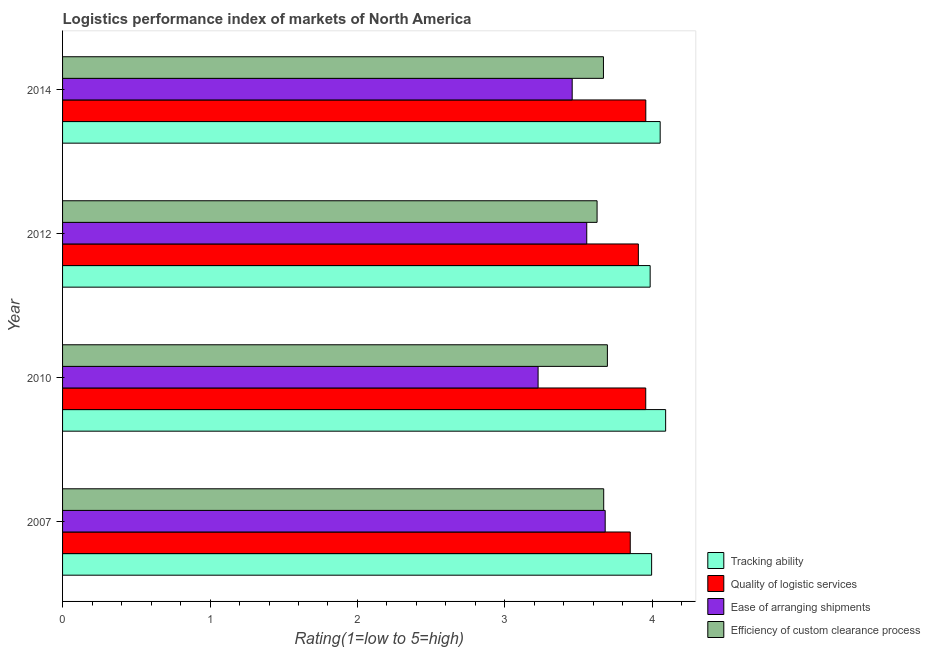How many different coloured bars are there?
Provide a short and direct response. 4. Are the number of bars per tick equal to the number of legend labels?
Give a very brief answer. Yes. In how many cases, is the number of bars for a given year not equal to the number of legend labels?
Ensure brevity in your answer.  0. What is the lpi rating of efficiency of custom clearance process in 2010?
Provide a short and direct response. 3.69. Across all years, what is the maximum lpi rating of quality of logistic services?
Give a very brief answer. 3.96. Across all years, what is the minimum lpi rating of efficiency of custom clearance process?
Your response must be concise. 3.62. In which year was the lpi rating of quality of logistic services maximum?
Offer a very short reply. 2014. In which year was the lpi rating of efficiency of custom clearance process minimum?
Ensure brevity in your answer.  2012. What is the total lpi rating of ease of arranging shipments in the graph?
Your answer should be compact. 13.92. What is the difference between the lpi rating of ease of arranging shipments in 2014 and the lpi rating of efficiency of custom clearance process in 2007?
Provide a succinct answer. -0.21. What is the average lpi rating of quality of logistic services per year?
Ensure brevity in your answer.  3.92. In the year 2014, what is the difference between the lpi rating of ease of arranging shipments and lpi rating of efficiency of custom clearance process?
Your answer should be compact. -0.21. Is the lpi rating of ease of arranging shipments in 2012 less than that in 2014?
Your answer should be compact. No. Is the difference between the lpi rating of quality of logistic services in 2007 and 2010 greater than the difference between the lpi rating of tracking ability in 2007 and 2010?
Your answer should be very brief. No. What is the difference between the highest and the lowest lpi rating of quality of logistic services?
Your answer should be very brief. 0.11. Is the sum of the lpi rating of ease of arranging shipments in 2010 and 2014 greater than the maximum lpi rating of efficiency of custom clearance process across all years?
Offer a terse response. Yes. Is it the case that in every year, the sum of the lpi rating of tracking ability and lpi rating of ease of arranging shipments is greater than the sum of lpi rating of quality of logistic services and lpi rating of efficiency of custom clearance process?
Provide a succinct answer. No. What does the 4th bar from the top in 2010 represents?
Make the answer very short. Tracking ability. What does the 4th bar from the bottom in 2012 represents?
Offer a terse response. Efficiency of custom clearance process. Is it the case that in every year, the sum of the lpi rating of tracking ability and lpi rating of quality of logistic services is greater than the lpi rating of ease of arranging shipments?
Keep it short and to the point. Yes. Are the values on the major ticks of X-axis written in scientific E-notation?
Offer a very short reply. No. Does the graph contain any zero values?
Provide a succinct answer. No. Does the graph contain grids?
Provide a short and direct response. No. Where does the legend appear in the graph?
Your response must be concise. Bottom right. How are the legend labels stacked?
Make the answer very short. Vertical. What is the title of the graph?
Provide a short and direct response. Logistics performance index of markets of North America. Does "Fiscal policy" appear as one of the legend labels in the graph?
Give a very brief answer. No. What is the label or title of the X-axis?
Make the answer very short. Rating(1=low to 5=high). What is the label or title of the Y-axis?
Offer a very short reply. Year. What is the Rating(1=low to 5=high) in Tracking ability in 2007?
Your answer should be very brief. 4. What is the Rating(1=low to 5=high) in Quality of logistic services in 2007?
Make the answer very short. 3.85. What is the Rating(1=low to 5=high) in Ease of arranging shipments in 2007?
Your answer should be very brief. 3.68. What is the Rating(1=low to 5=high) of Efficiency of custom clearance process in 2007?
Keep it short and to the point. 3.67. What is the Rating(1=low to 5=high) in Tracking ability in 2010?
Make the answer very short. 4.09. What is the Rating(1=low to 5=high) in Quality of logistic services in 2010?
Offer a very short reply. 3.96. What is the Rating(1=low to 5=high) in Ease of arranging shipments in 2010?
Provide a short and direct response. 3.23. What is the Rating(1=low to 5=high) in Efficiency of custom clearance process in 2010?
Ensure brevity in your answer.  3.69. What is the Rating(1=low to 5=high) of Tracking ability in 2012?
Provide a succinct answer. 3.98. What is the Rating(1=low to 5=high) in Quality of logistic services in 2012?
Give a very brief answer. 3.9. What is the Rating(1=low to 5=high) in Ease of arranging shipments in 2012?
Make the answer very short. 3.56. What is the Rating(1=low to 5=high) of Efficiency of custom clearance process in 2012?
Your answer should be compact. 3.62. What is the Rating(1=low to 5=high) in Tracking ability in 2014?
Offer a very short reply. 4.05. What is the Rating(1=low to 5=high) in Quality of logistic services in 2014?
Make the answer very short. 3.96. What is the Rating(1=low to 5=high) of Ease of arranging shipments in 2014?
Provide a succinct answer. 3.46. What is the Rating(1=low to 5=high) of Efficiency of custom clearance process in 2014?
Provide a succinct answer. 3.67. Across all years, what is the maximum Rating(1=low to 5=high) in Tracking ability?
Provide a succinct answer. 4.09. Across all years, what is the maximum Rating(1=low to 5=high) in Quality of logistic services?
Give a very brief answer. 3.96. Across all years, what is the maximum Rating(1=low to 5=high) of Ease of arranging shipments?
Ensure brevity in your answer.  3.68. Across all years, what is the maximum Rating(1=low to 5=high) of Efficiency of custom clearance process?
Provide a succinct answer. 3.69. Across all years, what is the minimum Rating(1=low to 5=high) in Tracking ability?
Make the answer very short. 3.98. Across all years, what is the minimum Rating(1=low to 5=high) of Quality of logistic services?
Offer a very short reply. 3.85. Across all years, what is the minimum Rating(1=low to 5=high) of Ease of arranging shipments?
Make the answer very short. 3.23. Across all years, what is the minimum Rating(1=low to 5=high) in Efficiency of custom clearance process?
Provide a short and direct response. 3.62. What is the total Rating(1=low to 5=high) of Tracking ability in the graph?
Your answer should be compact. 16.12. What is the total Rating(1=low to 5=high) of Quality of logistic services in the graph?
Keep it short and to the point. 15.67. What is the total Rating(1=low to 5=high) of Ease of arranging shipments in the graph?
Offer a very short reply. 13.92. What is the total Rating(1=low to 5=high) of Efficiency of custom clearance process in the graph?
Keep it short and to the point. 14.66. What is the difference between the Rating(1=low to 5=high) of Tracking ability in 2007 and that in 2010?
Give a very brief answer. -0.1. What is the difference between the Rating(1=low to 5=high) of Quality of logistic services in 2007 and that in 2010?
Give a very brief answer. -0.1. What is the difference between the Rating(1=low to 5=high) in Ease of arranging shipments in 2007 and that in 2010?
Offer a terse response. 0.46. What is the difference between the Rating(1=low to 5=high) of Efficiency of custom clearance process in 2007 and that in 2010?
Offer a terse response. -0.03. What is the difference between the Rating(1=low to 5=high) of Quality of logistic services in 2007 and that in 2012?
Your answer should be very brief. -0.06. What is the difference between the Rating(1=low to 5=high) of Ease of arranging shipments in 2007 and that in 2012?
Your response must be concise. 0.12. What is the difference between the Rating(1=low to 5=high) in Efficiency of custom clearance process in 2007 and that in 2012?
Offer a very short reply. 0.04. What is the difference between the Rating(1=low to 5=high) in Tracking ability in 2007 and that in 2014?
Provide a succinct answer. -0.06. What is the difference between the Rating(1=low to 5=high) of Quality of logistic services in 2007 and that in 2014?
Provide a succinct answer. -0.11. What is the difference between the Rating(1=low to 5=high) in Ease of arranging shipments in 2007 and that in 2014?
Offer a very short reply. 0.22. What is the difference between the Rating(1=low to 5=high) in Efficiency of custom clearance process in 2007 and that in 2014?
Make the answer very short. 0. What is the difference between the Rating(1=low to 5=high) of Tracking ability in 2010 and that in 2012?
Keep it short and to the point. 0.1. What is the difference between the Rating(1=low to 5=high) in Quality of logistic services in 2010 and that in 2012?
Your answer should be very brief. 0.05. What is the difference between the Rating(1=low to 5=high) in Ease of arranging shipments in 2010 and that in 2012?
Provide a short and direct response. -0.33. What is the difference between the Rating(1=low to 5=high) in Efficiency of custom clearance process in 2010 and that in 2012?
Ensure brevity in your answer.  0.07. What is the difference between the Rating(1=low to 5=high) in Tracking ability in 2010 and that in 2014?
Provide a succinct answer. 0.04. What is the difference between the Rating(1=low to 5=high) of Quality of logistic services in 2010 and that in 2014?
Your answer should be very brief. -0. What is the difference between the Rating(1=low to 5=high) of Ease of arranging shipments in 2010 and that in 2014?
Your response must be concise. -0.23. What is the difference between the Rating(1=low to 5=high) of Efficiency of custom clearance process in 2010 and that in 2014?
Keep it short and to the point. 0.03. What is the difference between the Rating(1=low to 5=high) in Tracking ability in 2012 and that in 2014?
Your answer should be compact. -0.07. What is the difference between the Rating(1=low to 5=high) in Quality of logistic services in 2012 and that in 2014?
Your response must be concise. -0.05. What is the difference between the Rating(1=low to 5=high) in Ease of arranging shipments in 2012 and that in 2014?
Your response must be concise. 0.1. What is the difference between the Rating(1=low to 5=high) of Efficiency of custom clearance process in 2012 and that in 2014?
Your response must be concise. -0.04. What is the difference between the Rating(1=low to 5=high) in Tracking ability in 2007 and the Rating(1=low to 5=high) in Ease of arranging shipments in 2010?
Provide a short and direct response. 0.77. What is the difference between the Rating(1=low to 5=high) of Quality of logistic services in 2007 and the Rating(1=low to 5=high) of Ease of arranging shipments in 2010?
Provide a succinct answer. 0.62. What is the difference between the Rating(1=low to 5=high) of Quality of logistic services in 2007 and the Rating(1=low to 5=high) of Efficiency of custom clearance process in 2010?
Give a very brief answer. 0.15. What is the difference between the Rating(1=low to 5=high) of Ease of arranging shipments in 2007 and the Rating(1=low to 5=high) of Efficiency of custom clearance process in 2010?
Your answer should be very brief. -0.01. What is the difference between the Rating(1=low to 5=high) of Tracking ability in 2007 and the Rating(1=low to 5=high) of Quality of logistic services in 2012?
Offer a very short reply. 0.09. What is the difference between the Rating(1=low to 5=high) of Tracking ability in 2007 and the Rating(1=low to 5=high) of Ease of arranging shipments in 2012?
Your response must be concise. 0.44. What is the difference between the Rating(1=low to 5=high) in Tracking ability in 2007 and the Rating(1=low to 5=high) in Efficiency of custom clearance process in 2012?
Keep it short and to the point. 0.37. What is the difference between the Rating(1=low to 5=high) of Quality of logistic services in 2007 and the Rating(1=low to 5=high) of Ease of arranging shipments in 2012?
Provide a short and direct response. 0.29. What is the difference between the Rating(1=low to 5=high) of Quality of logistic services in 2007 and the Rating(1=low to 5=high) of Efficiency of custom clearance process in 2012?
Your response must be concise. 0.23. What is the difference between the Rating(1=low to 5=high) of Ease of arranging shipments in 2007 and the Rating(1=low to 5=high) of Efficiency of custom clearance process in 2012?
Give a very brief answer. 0.06. What is the difference between the Rating(1=low to 5=high) of Tracking ability in 2007 and the Rating(1=low to 5=high) of Quality of logistic services in 2014?
Provide a succinct answer. 0.04. What is the difference between the Rating(1=low to 5=high) in Tracking ability in 2007 and the Rating(1=low to 5=high) in Ease of arranging shipments in 2014?
Your answer should be very brief. 0.54. What is the difference between the Rating(1=low to 5=high) in Tracking ability in 2007 and the Rating(1=low to 5=high) in Efficiency of custom clearance process in 2014?
Provide a succinct answer. 0.33. What is the difference between the Rating(1=low to 5=high) of Quality of logistic services in 2007 and the Rating(1=low to 5=high) of Ease of arranging shipments in 2014?
Offer a terse response. 0.39. What is the difference between the Rating(1=low to 5=high) in Quality of logistic services in 2007 and the Rating(1=low to 5=high) in Efficiency of custom clearance process in 2014?
Make the answer very short. 0.18. What is the difference between the Rating(1=low to 5=high) in Ease of arranging shipments in 2007 and the Rating(1=low to 5=high) in Efficiency of custom clearance process in 2014?
Provide a short and direct response. 0.01. What is the difference between the Rating(1=low to 5=high) in Tracking ability in 2010 and the Rating(1=low to 5=high) in Quality of logistic services in 2012?
Keep it short and to the point. 0.18. What is the difference between the Rating(1=low to 5=high) in Tracking ability in 2010 and the Rating(1=low to 5=high) in Ease of arranging shipments in 2012?
Offer a very short reply. 0.54. What is the difference between the Rating(1=low to 5=high) of Tracking ability in 2010 and the Rating(1=low to 5=high) of Efficiency of custom clearance process in 2012?
Make the answer very short. 0.47. What is the difference between the Rating(1=low to 5=high) of Quality of logistic services in 2010 and the Rating(1=low to 5=high) of Ease of arranging shipments in 2012?
Ensure brevity in your answer.  0.4. What is the difference between the Rating(1=low to 5=high) of Quality of logistic services in 2010 and the Rating(1=low to 5=high) of Efficiency of custom clearance process in 2012?
Provide a short and direct response. 0.33. What is the difference between the Rating(1=low to 5=high) in Ease of arranging shipments in 2010 and the Rating(1=low to 5=high) in Efficiency of custom clearance process in 2012?
Your answer should be very brief. -0.4. What is the difference between the Rating(1=low to 5=high) of Tracking ability in 2010 and the Rating(1=low to 5=high) of Quality of logistic services in 2014?
Keep it short and to the point. 0.13. What is the difference between the Rating(1=low to 5=high) of Tracking ability in 2010 and the Rating(1=low to 5=high) of Ease of arranging shipments in 2014?
Offer a very short reply. 0.63. What is the difference between the Rating(1=low to 5=high) of Tracking ability in 2010 and the Rating(1=low to 5=high) of Efficiency of custom clearance process in 2014?
Keep it short and to the point. 0.42. What is the difference between the Rating(1=low to 5=high) in Quality of logistic services in 2010 and the Rating(1=low to 5=high) in Ease of arranging shipments in 2014?
Keep it short and to the point. 0.5. What is the difference between the Rating(1=low to 5=high) in Quality of logistic services in 2010 and the Rating(1=low to 5=high) in Efficiency of custom clearance process in 2014?
Offer a terse response. 0.29. What is the difference between the Rating(1=low to 5=high) of Ease of arranging shipments in 2010 and the Rating(1=low to 5=high) of Efficiency of custom clearance process in 2014?
Ensure brevity in your answer.  -0.44. What is the difference between the Rating(1=low to 5=high) of Tracking ability in 2012 and the Rating(1=low to 5=high) of Quality of logistic services in 2014?
Give a very brief answer. 0.03. What is the difference between the Rating(1=low to 5=high) in Tracking ability in 2012 and the Rating(1=low to 5=high) in Ease of arranging shipments in 2014?
Provide a short and direct response. 0.53. What is the difference between the Rating(1=low to 5=high) in Tracking ability in 2012 and the Rating(1=low to 5=high) in Efficiency of custom clearance process in 2014?
Offer a terse response. 0.32. What is the difference between the Rating(1=low to 5=high) of Quality of logistic services in 2012 and the Rating(1=low to 5=high) of Ease of arranging shipments in 2014?
Provide a short and direct response. 0.45. What is the difference between the Rating(1=low to 5=high) of Quality of logistic services in 2012 and the Rating(1=low to 5=high) of Efficiency of custom clearance process in 2014?
Your answer should be compact. 0.24. What is the difference between the Rating(1=low to 5=high) in Ease of arranging shipments in 2012 and the Rating(1=low to 5=high) in Efficiency of custom clearance process in 2014?
Ensure brevity in your answer.  -0.11. What is the average Rating(1=low to 5=high) in Tracking ability per year?
Offer a terse response. 4.03. What is the average Rating(1=low to 5=high) of Quality of logistic services per year?
Keep it short and to the point. 3.92. What is the average Rating(1=low to 5=high) of Ease of arranging shipments per year?
Give a very brief answer. 3.48. What is the average Rating(1=low to 5=high) in Efficiency of custom clearance process per year?
Offer a terse response. 3.66. In the year 2007, what is the difference between the Rating(1=low to 5=high) in Tracking ability and Rating(1=low to 5=high) in Quality of logistic services?
Your response must be concise. 0.14. In the year 2007, what is the difference between the Rating(1=low to 5=high) of Tracking ability and Rating(1=low to 5=high) of Ease of arranging shipments?
Ensure brevity in your answer.  0.32. In the year 2007, what is the difference between the Rating(1=low to 5=high) of Tracking ability and Rating(1=low to 5=high) of Efficiency of custom clearance process?
Provide a succinct answer. 0.33. In the year 2007, what is the difference between the Rating(1=low to 5=high) in Quality of logistic services and Rating(1=low to 5=high) in Ease of arranging shipments?
Make the answer very short. 0.17. In the year 2007, what is the difference between the Rating(1=low to 5=high) of Quality of logistic services and Rating(1=low to 5=high) of Efficiency of custom clearance process?
Offer a terse response. 0.18. In the year 2007, what is the difference between the Rating(1=low to 5=high) of Ease of arranging shipments and Rating(1=low to 5=high) of Efficiency of custom clearance process?
Your answer should be very brief. 0.01. In the year 2010, what is the difference between the Rating(1=low to 5=high) of Tracking ability and Rating(1=low to 5=high) of Quality of logistic services?
Your answer should be very brief. 0.14. In the year 2010, what is the difference between the Rating(1=low to 5=high) in Tracking ability and Rating(1=low to 5=high) in Ease of arranging shipments?
Keep it short and to the point. 0.86. In the year 2010, what is the difference between the Rating(1=low to 5=high) in Tracking ability and Rating(1=low to 5=high) in Efficiency of custom clearance process?
Make the answer very short. 0.4. In the year 2010, what is the difference between the Rating(1=low to 5=high) in Quality of logistic services and Rating(1=low to 5=high) in Ease of arranging shipments?
Keep it short and to the point. 0.73. In the year 2010, what is the difference between the Rating(1=low to 5=high) in Quality of logistic services and Rating(1=low to 5=high) in Efficiency of custom clearance process?
Your answer should be very brief. 0.26. In the year 2010, what is the difference between the Rating(1=low to 5=high) of Ease of arranging shipments and Rating(1=low to 5=high) of Efficiency of custom clearance process?
Your answer should be compact. -0.47. In the year 2012, what is the difference between the Rating(1=low to 5=high) in Tracking ability and Rating(1=low to 5=high) in Quality of logistic services?
Ensure brevity in your answer.  0.08. In the year 2012, what is the difference between the Rating(1=low to 5=high) in Tracking ability and Rating(1=low to 5=high) in Ease of arranging shipments?
Give a very brief answer. 0.43. In the year 2012, what is the difference between the Rating(1=low to 5=high) in Tracking ability and Rating(1=low to 5=high) in Efficiency of custom clearance process?
Your answer should be compact. 0.36. In the year 2012, what is the difference between the Rating(1=low to 5=high) of Quality of logistic services and Rating(1=low to 5=high) of Efficiency of custom clearance process?
Make the answer very short. 0.28. In the year 2012, what is the difference between the Rating(1=low to 5=high) in Ease of arranging shipments and Rating(1=low to 5=high) in Efficiency of custom clearance process?
Provide a succinct answer. -0.07. In the year 2014, what is the difference between the Rating(1=low to 5=high) in Tracking ability and Rating(1=low to 5=high) in Quality of logistic services?
Your response must be concise. 0.1. In the year 2014, what is the difference between the Rating(1=low to 5=high) in Tracking ability and Rating(1=low to 5=high) in Ease of arranging shipments?
Give a very brief answer. 0.6. In the year 2014, what is the difference between the Rating(1=low to 5=high) of Tracking ability and Rating(1=low to 5=high) of Efficiency of custom clearance process?
Provide a short and direct response. 0.38. In the year 2014, what is the difference between the Rating(1=low to 5=high) in Quality of logistic services and Rating(1=low to 5=high) in Ease of arranging shipments?
Keep it short and to the point. 0.5. In the year 2014, what is the difference between the Rating(1=low to 5=high) of Quality of logistic services and Rating(1=low to 5=high) of Efficiency of custom clearance process?
Provide a short and direct response. 0.29. In the year 2014, what is the difference between the Rating(1=low to 5=high) of Ease of arranging shipments and Rating(1=low to 5=high) of Efficiency of custom clearance process?
Ensure brevity in your answer.  -0.21. What is the ratio of the Rating(1=low to 5=high) of Tracking ability in 2007 to that in 2010?
Make the answer very short. 0.98. What is the ratio of the Rating(1=low to 5=high) in Quality of logistic services in 2007 to that in 2010?
Give a very brief answer. 0.97. What is the ratio of the Rating(1=low to 5=high) in Ease of arranging shipments in 2007 to that in 2010?
Your answer should be very brief. 1.14. What is the ratio of the Rating(1=low to 5=high) in Tracking ability in 2007 to that in 2012?
Ensure brevity in your answer.  1. What is the ratio of the Rating(1=low to 5=high) of Quality of logistic services in 2007 to that in 2012?
Give a very brief answer. 0.99. What is the ratio of the Rating(1=low to 5=high) of Ease of arranging shipments in 2007 to that in 2012?
Make the answer very short. 1.04. What is the ratio of the Rating(1=low to 5=high) of Efficiency of custom clearance process in 2007 to that in 2012?
Offer a terse response. 1.01. What is the ratio of the Rating(1=low to 5=high) in Tracking ability in 2007 to that in 2014?
Make the answer very short. 0.99. What is the ratio of the Rating(1=low to 5=high) in Quality of logistic services in 2007 to that in 2014?
Keep it short and to the point. 0.97. What is the ratio of the Rating(1=low to 5=high) of Ease of arranging shipments in 2007 to that in 2014?
Your answer should be compact. 1.06. What is the ratio of the Rating(1=low to 5=high) of Tracking ability in 2010 to that in 2012?
Provide a succinct answer. 1.03. What is the ratio of the Rating(1=low to 5=high) in Quality of logistic services in 2010 to that in 2012?
Keep it short and to the point. 1.01. What is the ratio of the Rating(1=low to 5=high) of Ease of arranging shipments in 2010 to that in 2012?
Ensure brevity in your answer.  0.91. What is the ratio of the Rating(1=low to 5=high) of Efficiency of custom clearance process in 2010 to that in 2012?
Offer a very short reply. 1.02. What is the ratio of the Rating(1=low to 5=high) in Tracking ability in 2010 to that in 2014?
Your answer should be very brief. 1.01. What is the ratio of the Rating(1=low to 5=high) of Quality of logistic services in 2010 to that in 2014?
Provide a succinct answer. 1. What is the ratio of the Rating(1=low to 5=high) in Ease of arranging shipments in 2010 to that in 2014?
Your response must be concise. 0.93. What is the ratio of the Rating(1=low to 5=high) of Efficiency of custom clearance process in 2010 to that in 2014?
Your response must be concise. 1.01. What is the ratio of the Rating(1=low to 5=high) in Tracking ability in 2012 to that in 2014?
Ensure brevity in your answer.  0.98. What is the ratio of the Rating(1=low to 5=high) in Quality of logistic services in 2012 to that in 2014?
Your response must be concise. 0.99. What is the ratio of the Rating(1=low to 5=high) of Ease of arranging shipments in 2012 to that in 2014?
Your answer should be compact. 1.03. What is the ratio of the Rating(1=low to 5=high) in Efficiency of custom clearance process in 2012 to that in 2014?
Your response must be concise. 0.99. What is the difference between the highest and the second highest Rating(1=low to 5=high) in Tracking ability?
Provide a short and direct response. 0.04. What is the difference between the highest and the second highest Rating(1=low to 5=high) in Quality of logistic services?
Provide a short and direct response. 0. What is the difference between the highest and the second highest Rating(1=low to 5=high) of Ease of arranging shipments?
Make the answer very short. 0.12. What is the difference between the highest and the second highest Rating(1=low to 5=high) of Efficiency of custom clearance process?
Keep it short and to the point. 0.03. What is the difference between the highest and the lowest Rating(1=low to 5=high) of Tracking ability?
Offer a terse response. 0.1. What is the difference between the highest and the lowest Rating(1=low to 5=high) in Quality of logistic services?
Your answer should be very brief. 0.11. What is the difference between the highest and the lowest Rating(1=low to 5=high) of Ease of arranging shipments?
Provide a succinct answer. 0.46. What is the difference between the highest and the lowest Rating(1=low to 5=high) in Efficiency of custom clearance process?
Keep it short and to the point. 0.07. 